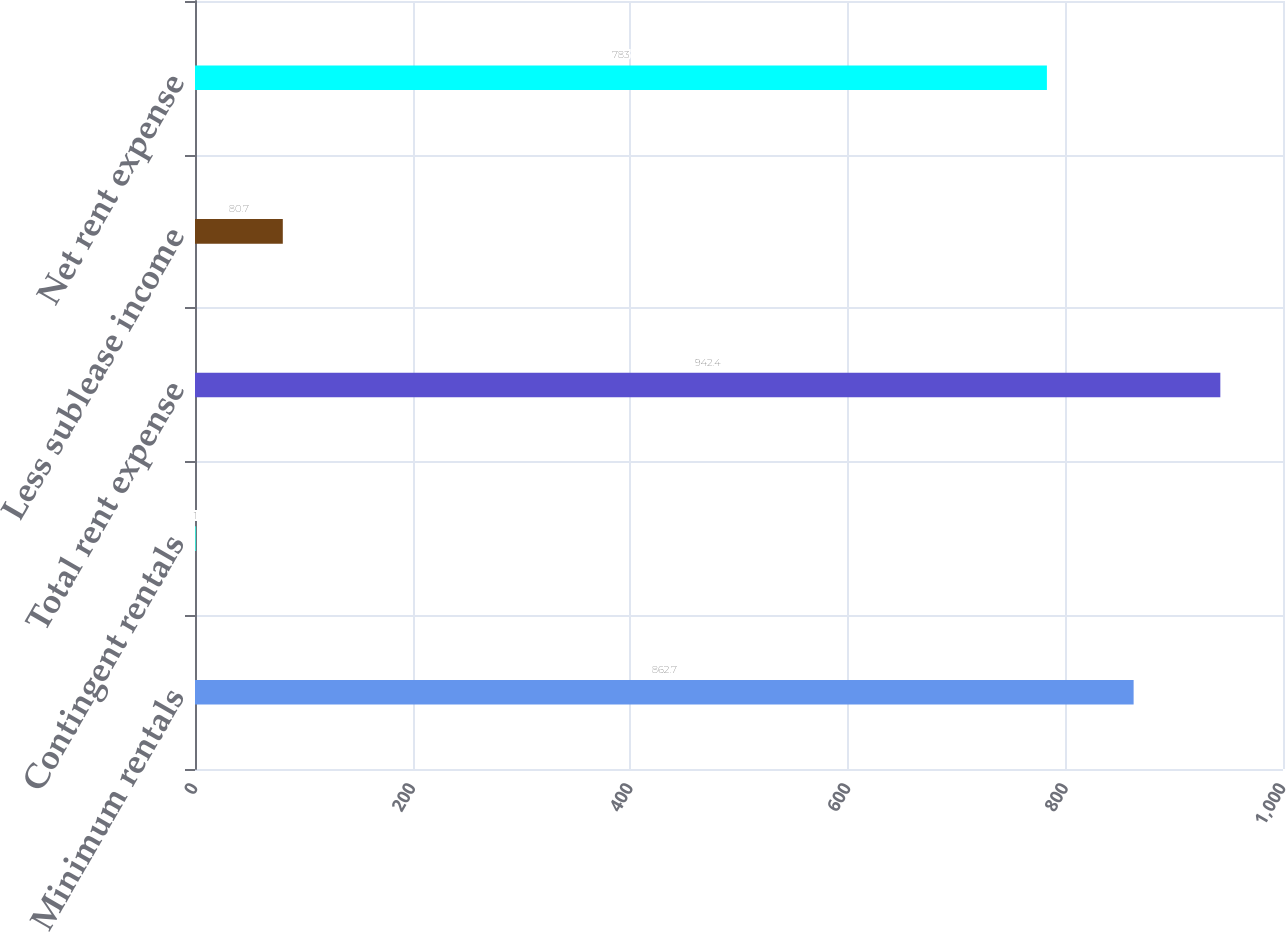Convert chart. <chart><loc_0><loc_0><loc_500><loc_500><bar_chart><fcel>Minimum rentals<fcel>Contingent rentals<fcel>Total rent expense<fcel>Less sublease income<fcel>Net rent expense<nl><fcel>862.7<fcel>1<fcel>942.4<fcel>80.7<fcel>783<nl></chart> 